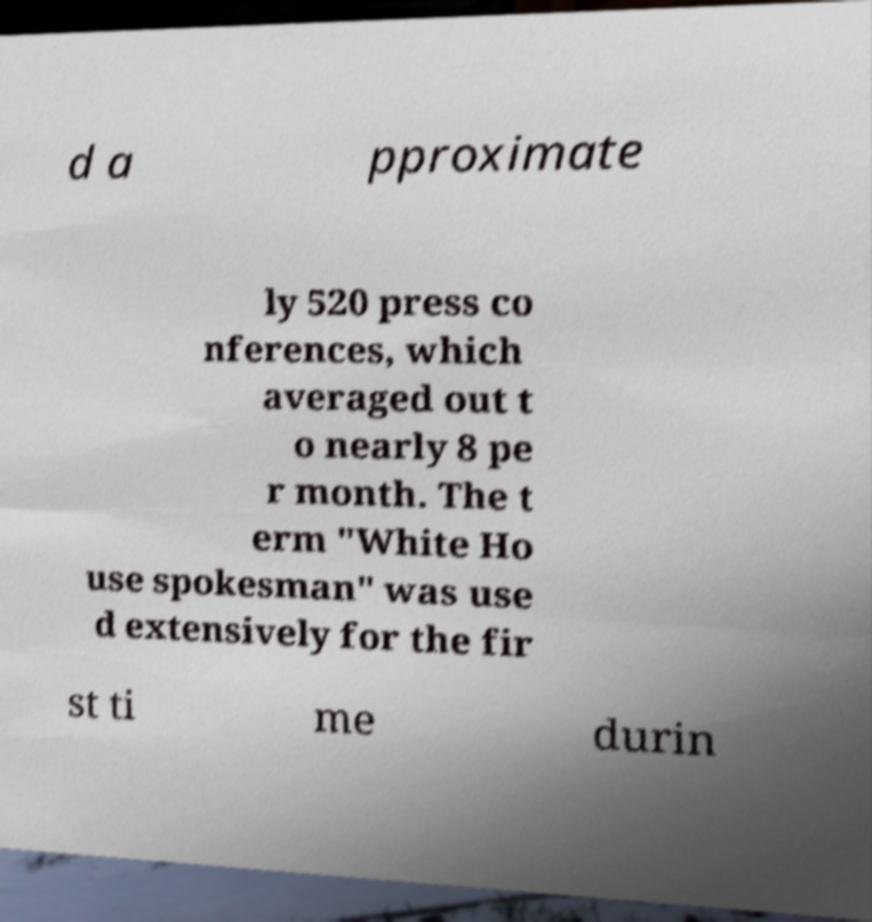Can you accurately transcribe the text from the provided image for me? d a pproximate ly 520 press co nferences, which averaged out t o nearly 8 pe r month. The t erm "White Ho use spokesman" was use d extensively for the fir st ti me durin 